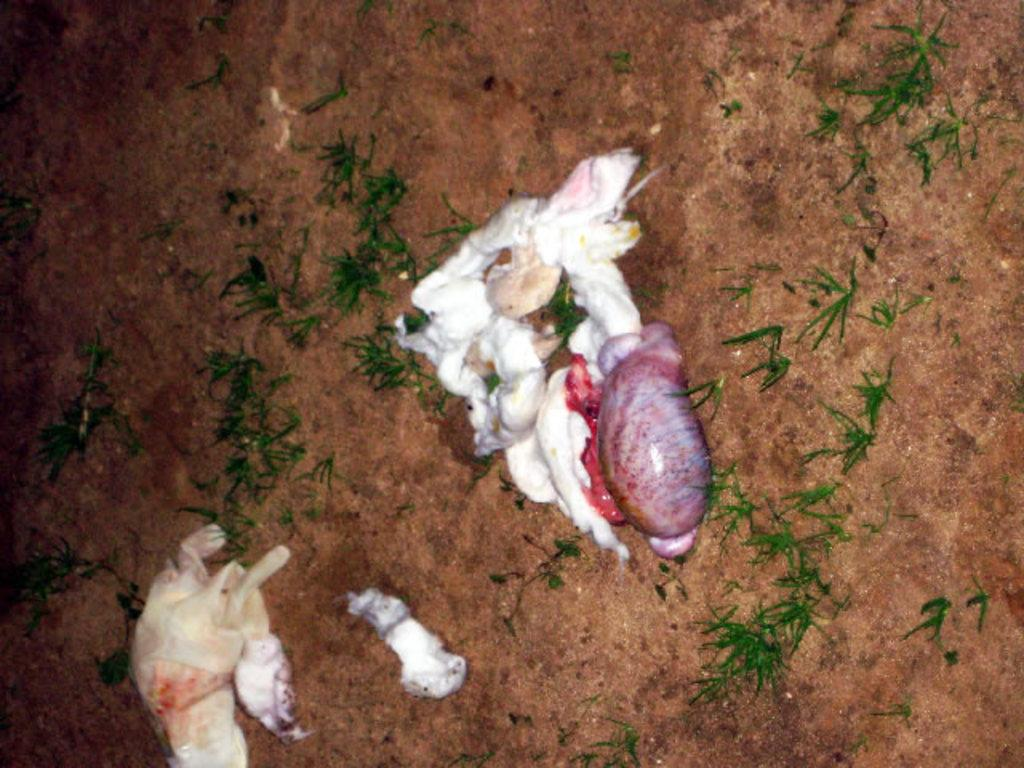What is covering the ground in the image? There is cotton on the ground in the image. Are there any other objects on the ground besides the cotton? Yes, there are other objects on the ground in the image. What type of vegetation can be seen on the right side of the image? There is green grass on the right side of the image. What type of soup is being served in the image? There is no soup present in the image; it features cotton on the ground and other objects on the ground. Can you see a hook hanging from the tree in the image? There is no tree or hook present in the image. 